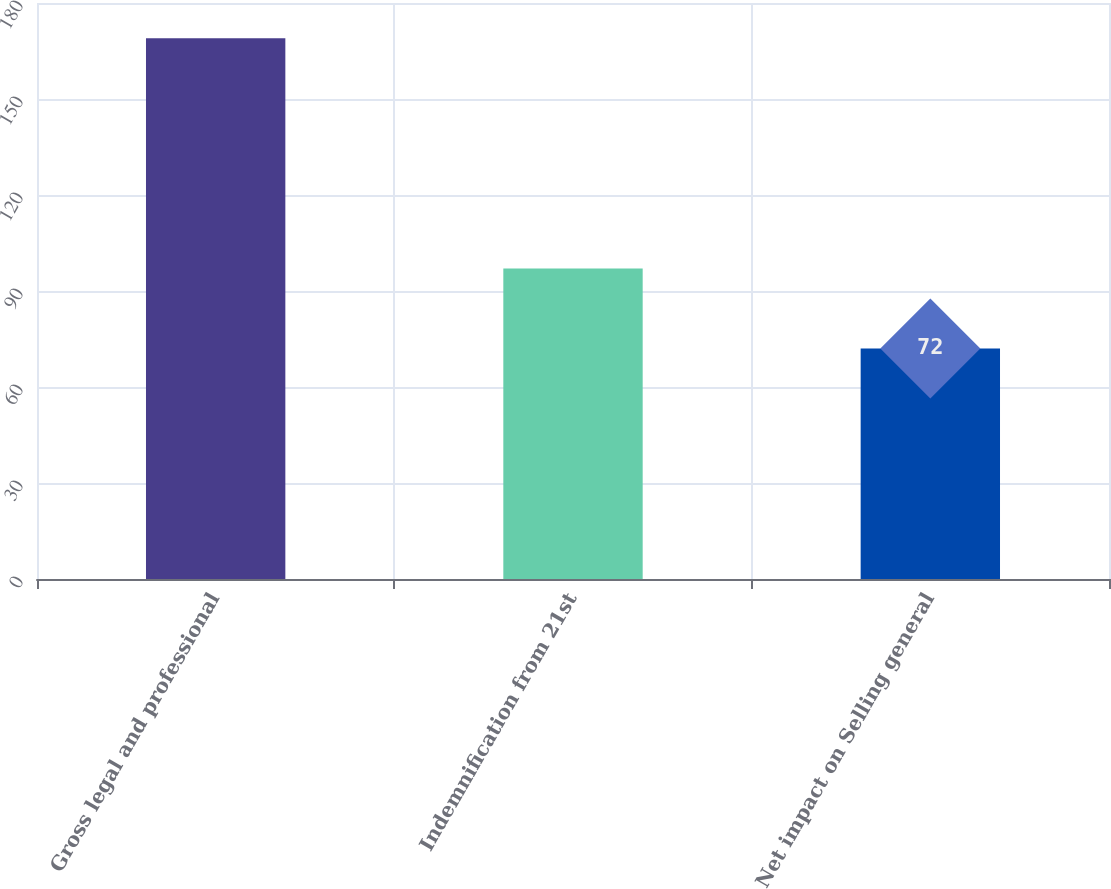<chart> <loc_0><loc_0><loc_500><loc_500><bar_chart><fcel>Gross legal and professional<fcel>Indemnification from 21st<fcel>Net impact on Selling general<nl><fcel>169<fcel>97<fcel>72<nl></chart> 